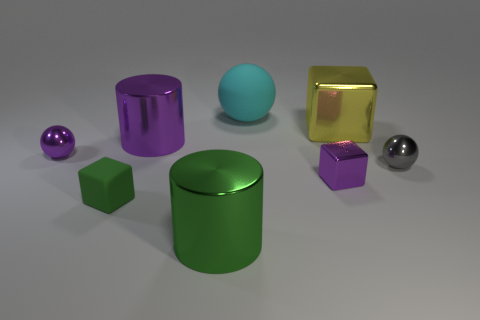What is the material of the purple thing left of the small green matte thing in front of the metal thing that is behind the purple cylinder?
Offer a very short reply. Metal. There is a big object in front of the tiny purple metal ball; what is its shape?
Ensure brevity in your answer.  Cylinder. The purple ball that is the same material as the tiny gray object is what size?
Your answer should be very brief. Small. What number of other tiny metal objects are the same shape as the small gray shiny object?
Your answer should be very brief. 1. Do the shiny thing that is left of the tiny green block and the big rubber object have the same color?
Give a very brief answer. No. What number of cyan matte objects are on the left side of the block behind the purple thing to the right of the large purple metallic cylinder?
Offer a very short reply. 1. What number of small purple objects are left of the big cyan matte sphere and right of the small green block?
Give a very brief answer. 0. There is a tiny object that is the same color as the tiny metal block; what is its shape?
Your response must be concise. Sphere. Are there any other things that are the same material as the purple cylinder?
Offer a very short reply. Yes. Do the small purple sphere and the yellow cube have the same material?
Offer a terse response. Yes. 